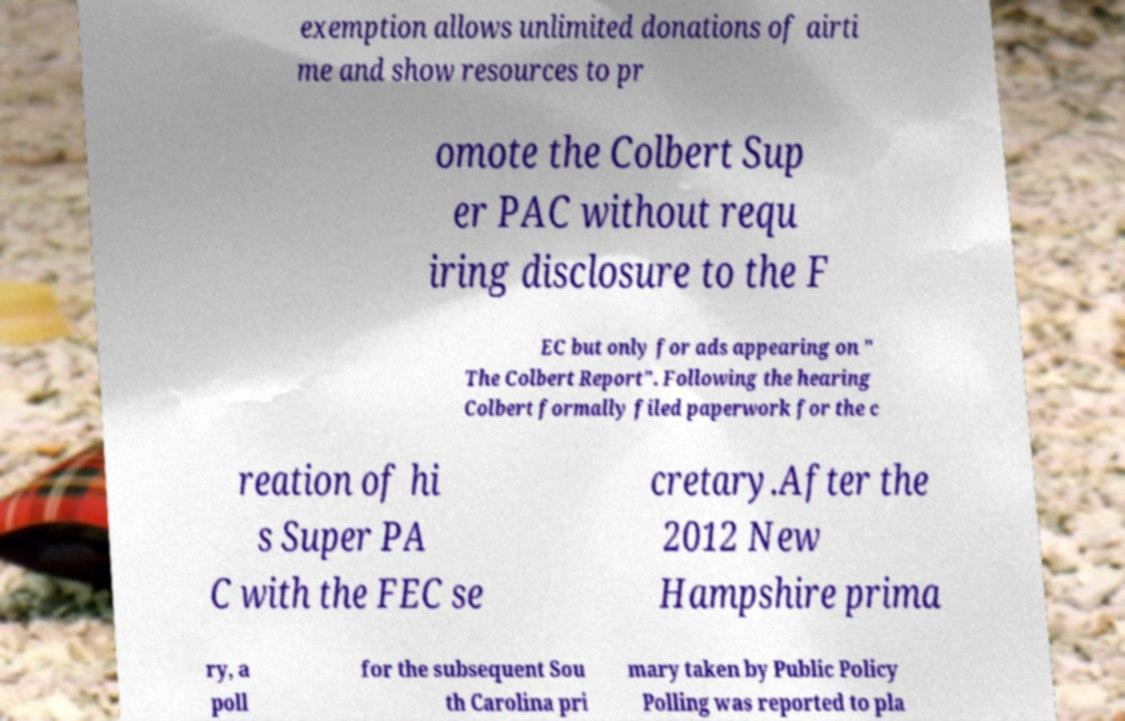For documentation purposes, I need the text within this image transcribed. Could you provide that? exemption allows unlimited donations of airti me and show resources to pr omote the Colbert Sup er PAC without requ iring disclosure to the F EC but only for ads appearing on " The Colbert Report". Following the hearing Colbert formally filed paperwork for the c reation of hi s Super PA C with the FEC se cretary.After the 2012 New Hampshire prima ry, a poll for the subsequent Sou th Carolina pri mary taken by Public Policy Polling was reported to pla 